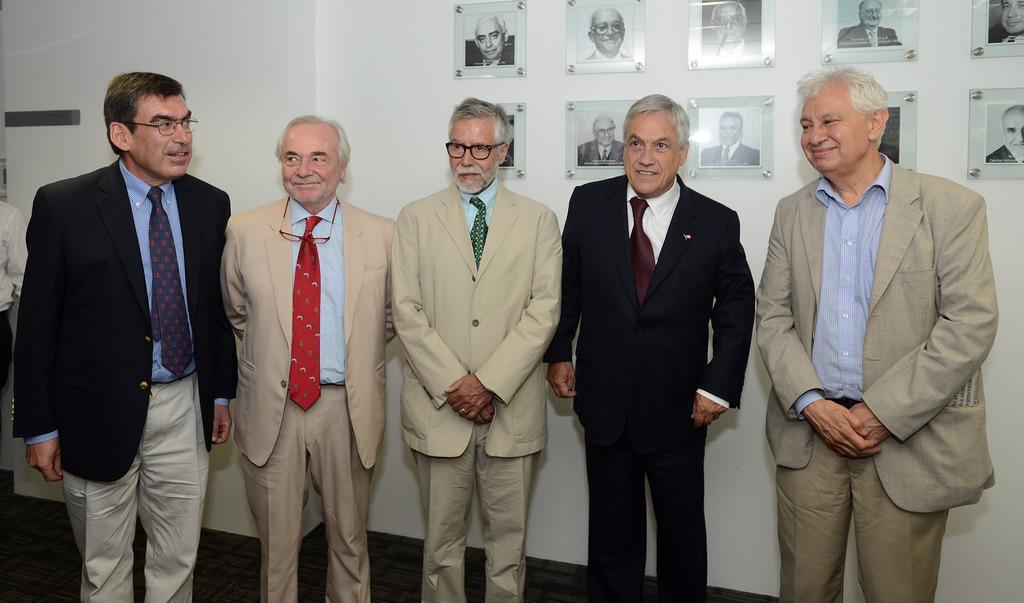Could you give a brief overview of what you see in this image? As we can see in the image there is a white color wall, photo frames and few people over here. 